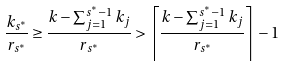Convert formula to latex. <formula><loc_0><loc_0><loc_500><loc_500>\frac { k _ { s ^ { * } } } { r _ { s ^ { * } } } \geq \frac { k - \sum _ { j = 1 } ^ { s ^ { * } - 1 } k _ { j } } { r _ { s ^ { * } } } > \left \lceil \frac { k - \sum _ { j = 1 } ^ { s ^ { * } - 1 } k _ { j } } { r _ { s ^ { * } } } \right \rceil - 1</formula> 